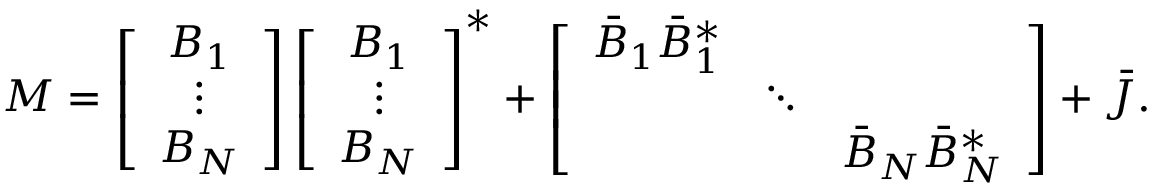<formula> <loc_0><loc_0><loc_500><loc_500>\begin{array} { r } { M = \left [ \begin{array} { c } { B _ { 1 } } \\ { \vdots } \\ { B _ { N } } \end{array} \right ] \left [ \begin{array} { c } { B _ { 1 } } \\ { \vdots } \\ { B _ { N } } \end{array} \right ] ^ { * } + \left [ \begin{array} { c c c } { \bar { B } _ { 1 } \bar { B } _ { 1 } ^ { * } } & & \\ & { \ddots } & \\ & & { \bar { B } _ { N } \bar { B } _ { N } ^ { * } } \end{array} \right ] + \bar { J } . } \end{array}</formula> 